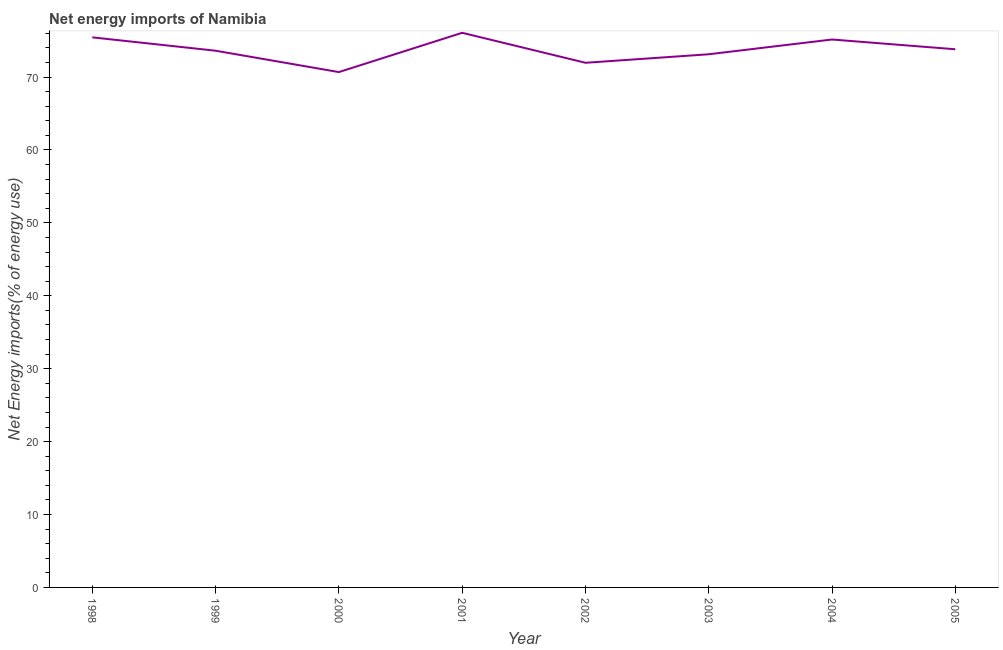What is the energy imports in 1999?
Keep it short and to the point. 73.61. Across all years, what is the maximum energy imports?
Give a very brief answer. 76.07. Across all years, what is the minimum energy imports?
Keep it short and to the point. 70.68. What is the sum of the energy imports?
Make the answer very short. 589.82. What is the difference between the energy imports in 2001 and 2005?
Provide a short and direct response. 2.26. What is the average energy imports per year?
Provide a succinct answer. 73.73. What is the median energy imports?
Offer a terse response. 73.71. In how many years, is the energy imports greater than 6 %?
Offer a terse response. 8. Do a majority of the years between 2001 and 2000 (inclusive) have energy imports greater than 26 %?
Your answer should be very brief. No. What is the ratio of the energy imports in 2002 to that in 2003?
Provide a succinct answer. 0.98. Is the energy imports in 2003 less than that in 2005?
Ensure brevity in your answer.  Yes. What is the difference between the highest and the second highest energy imports?
Offer a very short reply. 0.63. Is the sum of the energy imports in 2000 and 2005 greater than the maximum energy imports across all years?
Your answer should be compact. Yes. What is the difference between the highest and the lowest energy imports?
Give a very brief answer. 5.39. Does the energy imports monotonically increase over the years?
Your response must be concise. No. How many years are there in the graph?
Offer a very short reply. 8. Are the values on the major ticks of Y-axis written in scientific E-notation?
Keep it short and to the point. No. What is the title of the graph?
Provide a short and direct response. Net energy imports of Namibia. What is the label or title of the Y-axis?
Offer a very short reply. Net Energy imports(% of energy use). What is the Net Energy imports(% of energy use) in 1998?
Provide a succinct answer. 75.44. What is the Net Energy imports(% of energy use) in 1999?
Ensure brevity in your answer.  73.61. What is the Net Energy imports(% of energy use) of 2000?
Ensure brevity in your answer.  70.68. What is the Net Energy imports(% of energy use) of 2001?
Your answer should be compact. 76.07. What is the Net Energy imports(% of energy use) in 2002?
Provide a succinct answer. 71.95. What is the Net Energy imports(% of energy use) of 2003?
Provide a succinct answer. 73.12. What is the Net Energy imports(% of energy use) in 2004?
Your answer should be compact. 75.14. What is the Net Energy imports(% of energy use) in 2005?
Ensure brevity in your answer.  73.81. What is the difference between the Net Energy imports(% of energy use) in 1998 and 1999?
Your answer should be compact. 1.83. What is the difference between the Net Energy imports(% of energy use) in 1998 and 2000?
Keep it short and to the point. 4.76. What is the difference between the Net Energy imports(% of energy use) in 1998 and 2001?
Your answer should be compact. -0.63. What is the difference between the Net Energy imports(% of energy use) in 1998 and 2002?
Your answer should be very brief. 3.49. What is the difference between the Net Energy imports(% of energy use) in 1998 and 2003?
Keep it short and to the point. 2.32. What is the difference between the Net Energy imports(% of energy use) in 1998 and 2004?
Offer a terse response. 0.3. What is the difference between the Net Energy imports(% of energy use) in 1998 and 2005?
Make the answer very short. 1.63. What is the difference between the Net Energy imports(% of energy use) in 1999 and 2000?
Provide a succinct answer. 2.93. What is the difference between the Net Energy imports(% of energy use) in 1999 and 2001?
Ensure brevity in your answer.  -2.46. What is the difference between the Net Energy imports(% of energy use) in 1999 and 2002?
Offer a very short reply. 1.65. What is the difference between the Net Energy imports(% of energy use) in 1999 and 2003?
Your answer should be compact. 0.49. What is the difference between the Net Energy imports(% of energy use) in 1999 and 2004?
Your answer should be compact. -1.54. What is the difference between the Net Energy imports(% of energy use) in 1999 and 2005?
Give a very brief answer. -0.2. What is the difference between the Net Energy imports(% of energy use) in 2000 and 2001?
Keep it short and to the point. -5.39. What is the difference between the Net Energy imports(% of energy use) in 2000 and 2002?
Your answer should be compact. -1.28. What is the difference between the Net Energy imports(% of energy use) in 2000 and 2003?
Offer a terse response. -2.44. What is the difference between the Net Energy imports(% of energy use) in 2000 and 2004?
Offer a very short reply. -4.47. What is the difference between the Net Energy imports(% of energy use) in 2000 and 2005?
Your answer should be compact. -3.13. What is the difference between the Net Energy imports(% of energy use) in 2001 and 2002?
Make the answer very short. 4.11. What is the difference between the Net Energy imports(% of energy use) in 2001 and 2003?
Offer a very short reply. 2.95. What is the difference between the Net Energy imports(% of energy use) in 2001 and 2004?
Your answer should be compact. 0.92. What is the difference between the Net Energy imports(% of energy use) in 2001 and 2005?
Provide a succinct answer. 2.26. What is the difference between the Net Energy imports(% of energy use) in 2002 and 2003?
Provide a succinct answer. -1.17. What is the difference between the Net Energy imports(% of energy use) in 2002 and 2004?
Your response must be concise. -3.19. What is the difference between the Net Energy imports(% of energy use) in 2002 and 2005?
Offer a terse response. -1.85. What is the difference between the Net Energy imports(% of energy use) in 2003 and 2004?
Provide a succinct answer. -2.02. What is the difference between the Net Energy imports(% of energy use) in 2003 and 2005?
Your response must be concise. -0.69. What is the difference between the Net Energy imports(% of energy use) in 2004 and 2005?
Ensure brevity in your answer.  1.34. What is the ratio of the Net Energy imports(% of energy use) in 1998 to that in 2000?
Provide a short and direct response. 1.07. What is the ratio of the Net Energy imports(% of energy use) in 1998 to that in 2002?
Give a very brief answer. 1.05. What is the ratio of the Net Energy imports(% of energy use) in 1998 to that in 2003?
Provide a succinct answer. 1.03. What is the ratio of the Net Energy imports(% of energy use) in 1999 to that in 2000?
Offer a terse response. 1.04. What is the ratio of the Net Energy imports(% of energy use) in 1999 to that in 2002?
Your response must be concise. 1.02. What is the ratio of the Net Energy imports(% of energy use) in 1999 to that in 2004?
Your answer should be very brief. 0.98. What is the ratio of the Net Energy imports(% of energy use) in 1999 to that in 2005?
Offer a very short reply. 1. What is the ratio of the Net Energy imports(% of energy use) in 2000 to that in 2001?
Give a very brief answer. 0.93. What is the ratio of the Net Energy imports(% of energy use) in 2000 to that in 2002?
Keep it short and to the point. 0.98. What is the ratio of the Net Energy imports(% of energy use) in 2000 to that in 2003?
Give a very brief answer. 0.97. What is the ratio of the Net Energy imports(% of energy use) in 2000 to that in 2004?
Your response must be concise. 0.94. What is the ratio of the Net Energy imports(% of energy use) in 2000 to that in 2005?
Provide a short and direct response. 0.96. What is the ratio of the Net Energy imports(% of energy use) in 2001 to that in 2002?
Offer a very short reply. 1.06. What is the ratio of the Net Energy imports(% of energy use) in 2001 to that in 2005?
Ensure brevity in your answer.  1.03. What is the ratio of the Net Energy imports(% of energy use) in 2002 to that in 2004?
Your answer should be very brief. 0.96. What is the ratio of the Net Energy imports(% of energy use) in 2003 to that in 2004?
Provide a short and direct response. 0.97. 